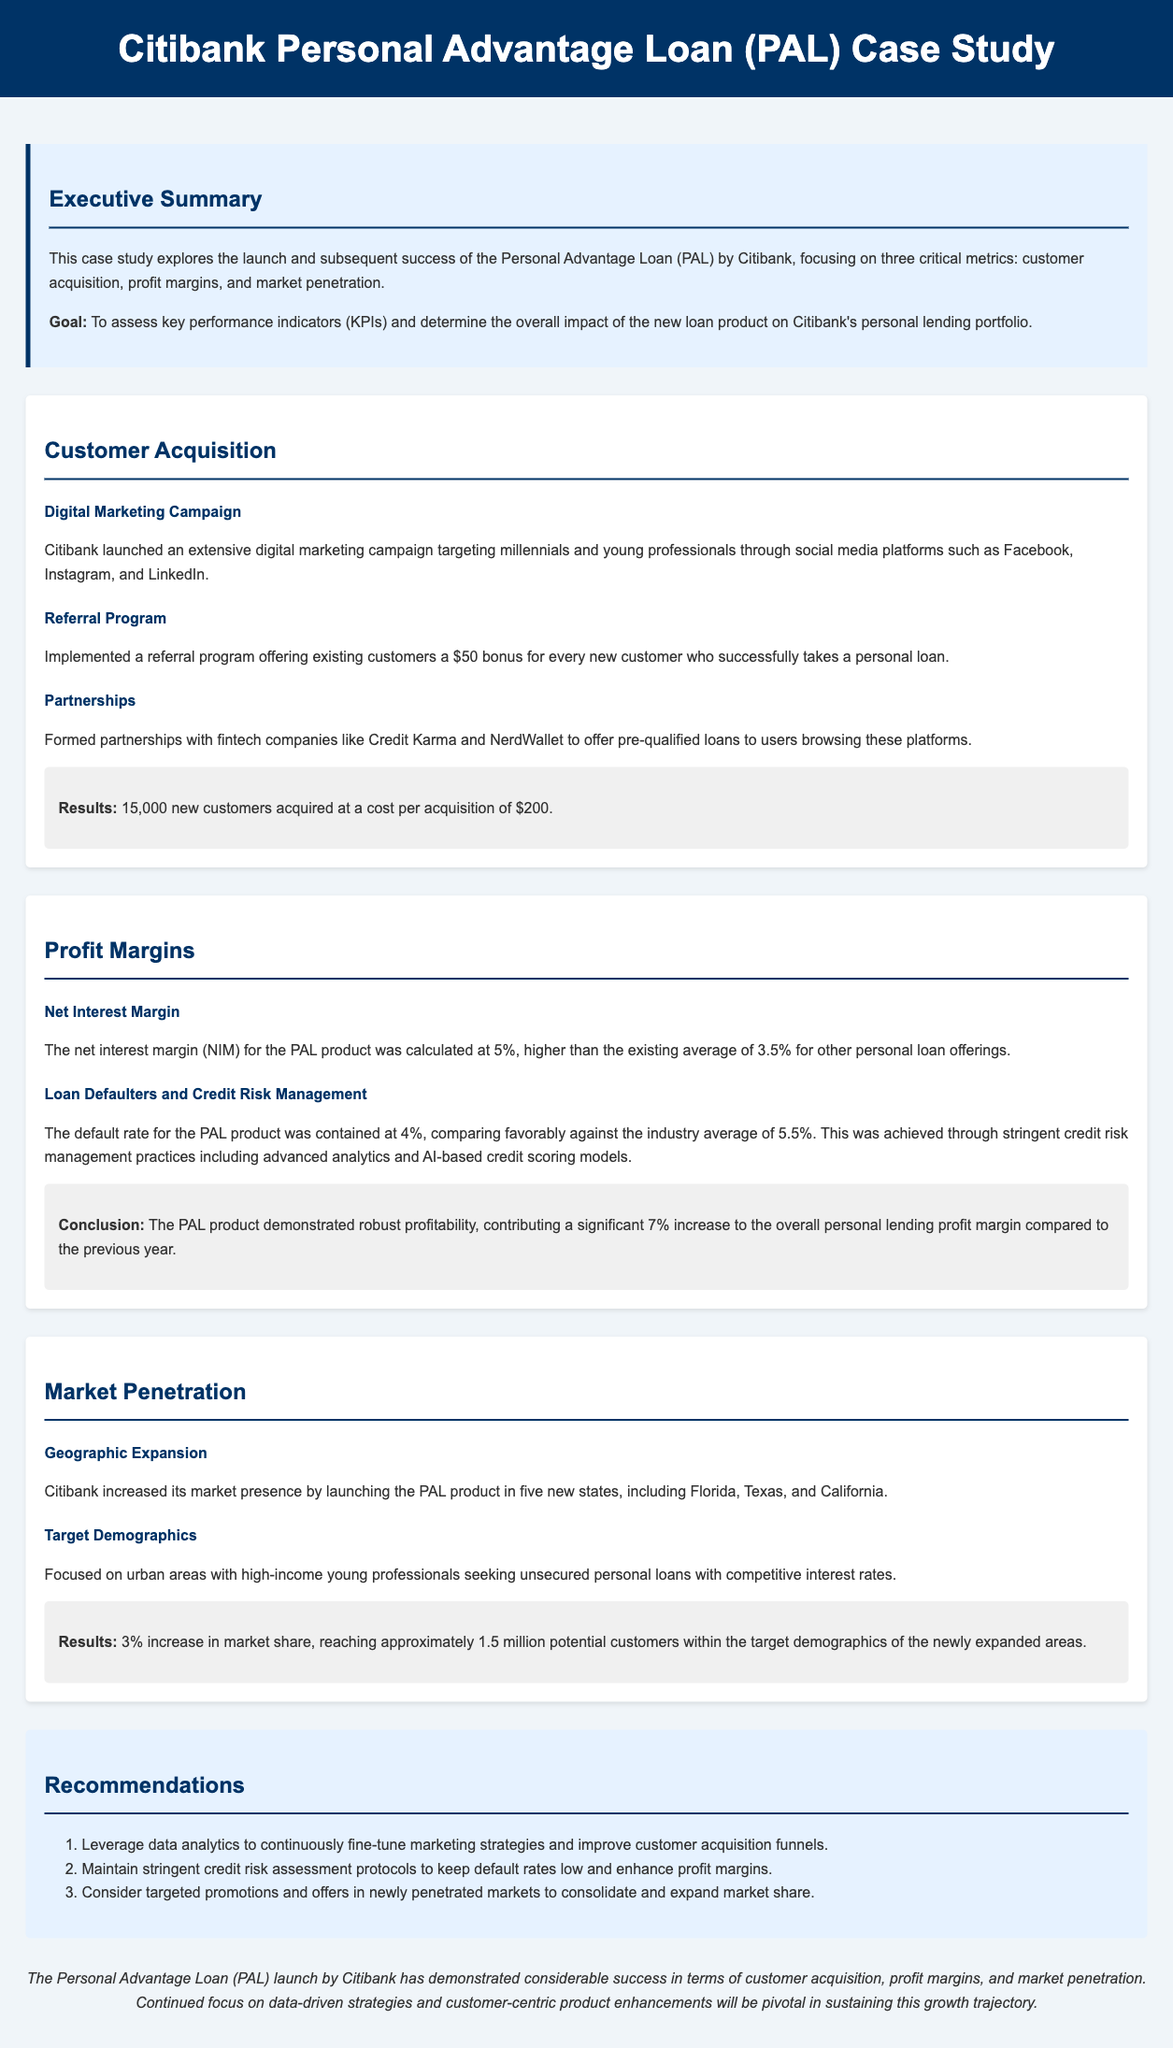What is the title of the case study? The title of the case study is explicitly mentioned at the beginning of the document.
Answer: Citibank Personal Advantage Loan (PAL) Case Study How many new customers were acquired? The document specifies the number of new customers acquired under the Customer Acquisition section.
Answer: 15,000 What was the net interest margin for the PAL product? The net interest margin for the PAL product is detailed in the Profit Margins section of the document.
Answer: 5% What percentage increase in market share was achieved? The increase in market share is noted in the Market Penetration section of the document.
Answer: 3% What was the default rate for the PAL product? The default rate is provided in the Profit Margins section, comparing it against industry averages.
Answer: 4% Which states did Citibank expand into? The document mentions the states in the Geographic Expansion strategy within the Market Penetration section.
Answer: Florida, Texas, and California What was the cost per acquisition for new customers? This cost is mentioned in the results section under Customer Acquisition.
Answer: $200 What is one recommendation mentioned in the study? The recommendations are listed at the end of the case study.
Answer: Leverage data analytics to continuously fine-tune marketing strategies and improve customer acquisition funnels 